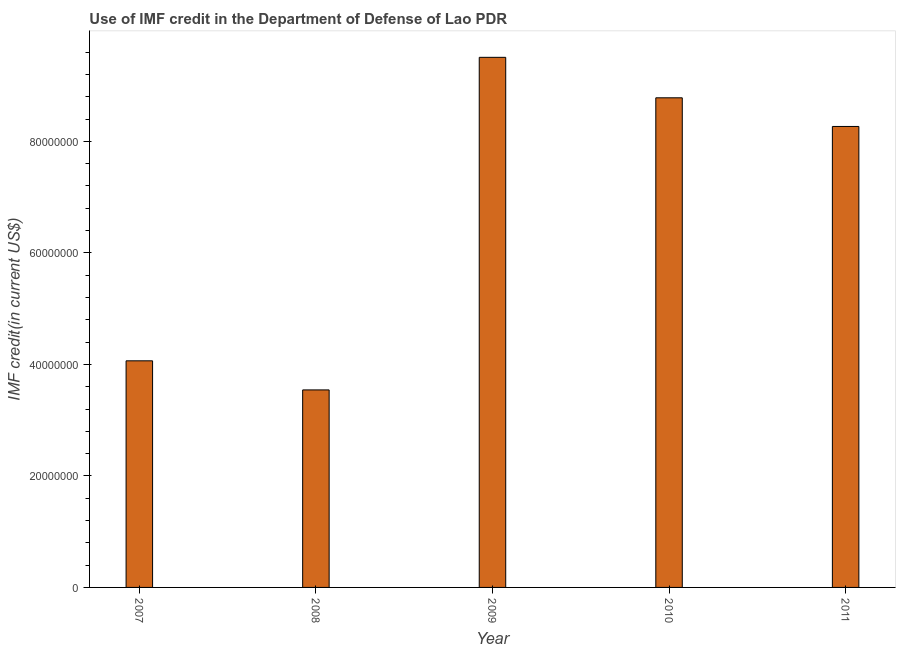Does the graph contain grids?
Your response must be concise. No. What is the title of the graph?
Your answer should be very brief. Use of IMF credit in the Department of Defense of Lao PDR. What is the label or title of the Y-axis?
Your answer should be very brief. IMF credit(in current US$). What is the use of imf credit in dod in 2011?
Your answer should be very brief. 8.27e+07. Across all years, what is the maximum use of imf credit in dod?
Keep it short and to the point. 9.51e+07. Across all years, what is the minimum use of imf credit in dod?
Offer a very short reply. 3.54e+07. In which year was the use of imf credit in dod maximum?
Offer a terse response. 2009. In which year was the use of imf credit in dod minimum?
Ensure brevity in your answer.  2008. What is the sum of the use of imf credit in dod?
Make the answer very short. 3.42e+08. What is the difference between the use of imf credit in dod in 2010 and 2011?
Give a very brief answer. 5.14e+06. What is the average use of imf credit in dod per year?
Offer a very short reply. 6.83e+07. What is the median use of imf credit in dod?
Your response must be concise. 8.27e+07. What is the ratio of the use of imf credit in dod in 2009 to that in 2011?
Offer a terse response. 1.15. What is the difference between the highest and the second highest use of imf credit in dod?
Provide a succinct answer. 7.26e+06. Is the sum of the use of imf credit in dod in 2009 and 2011 greater than the maximum use of imf credit in dod across all years?
Give a very brief answer. Yes. What is the difference between the highest and the lowest use of imf credit in dod?
Provide a short and direct response. 5.96e+07. In how many years, is the use of imf credit in dod greater than the average use of imf credit in dod taken over all years?
Provide a short and direct response. 3. How many bars are there?
Provide a succinct answer. 5. How many years are there in the graph?
Give a very brief answer. 5. What is the difference between two consecutive major ticks on the Y-axis?
Give a very brief answer. 2.00e+07. What is the IMF credit(in current US$) in 2007?
Ensure brevity in your answer.  4.06e+07. What is the IMF credit(in current US$) of 2008?
Your answer should be compact. 3.54e+07. What is the IMF credit(in current US$) of 2009?
Offer a very short reply. 9.51e+07. What is the IMF credit(in current US$) in 2010?
Offer a terse response. 8.78e+07. What is the IMF credit(in current US$) in 2011?
Ensure brevity in your answer.  8.27e+07. What is the difference between the IMF credit(in current US$) in 2007 and 2008?
Ensure brevity in your answer.  5.22e+06. What is the difference between the IMF credit(in current US$) in 2007 and 2009?
Your response must be concise. -5.44e+07. What is the difference between the IMF credit(in current US$) in 2007 and 2010?
Ensure brevity in your answer.  -4.72e+07. What is the difference between the IMF credit(in current US$) in 2007 and 2011?
Keep it short and to the point. -4.20e+07. What is the difference between the IMF credit(in current US$) in 2008 and 2009?
Ensure brevity in your answer.  -5.96e+07. What is the difference between the IMF credit(in current US$) in 2008 and 2010?
Ensure brevity in your answer.  -5.24e+07. What is the difference between the IMF credit(in current US$) in 2008 and 2011?
Your response must be concise. -4.72e+07. What is the difference between the IMF credit(in current US$) in 2009 and 2010?
Your answer should be very brief. 7.26e+06. What is the difference between the IMF credit(in current US$) in 2009 and 2011?
Ensure brevity in your answer.  1.24e+07. What is the difference between the IMF credit(in current US$) in 2010 and 2011?
Provide a succinct answer. 5.14e+06. What is the ratio of the IMF credit(in current US$) in 2007 to that in 2008?
Keep it short and to the point. 1.15. What is the ratio of the IMF credit(in current US$) in 2007 to that in 2009?
Offer a terse response. 0.43. What is the ratio of the IMF credit(in current US$) in 2007 to that in 2010?
Your response must be concise. 0.46. What is the ratio of the IMF credit(in current US$) in 2007 to that in 2011?
Provide a short and direct response. 0.49. What is the ratio of the IMF credit(in current US$) in 2008 to that in 2009?
Offer a very short reply. 0.37. What is the ratio of the IMF credit(in current US$) in 2008 to that in 2010?
Provide a succinct answer. 0.4. What is the ratio of the IMF credit(in current US$) in 2008 to that in 2011?
Your answer should be compact. 0.43. What is the ratio of the IMF credit(in current US$) in 2009 to that in 2010?
Keep it short and to the point. 1.08. What is the ratio of the IMF credit(in current US$) in 2009 to that in 2011?
Your answer should be very brief. 1.15. What is the ratio of the IMF credit(in current US$) in 2010 to that in 2011?
Your answer should be very brief. 1.06. 